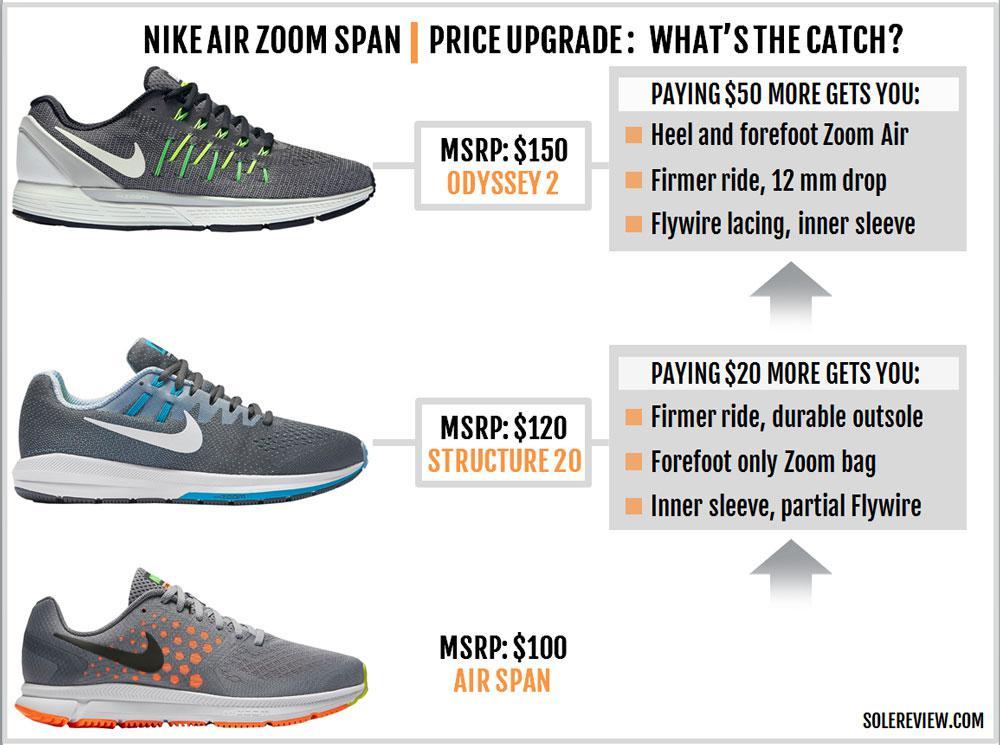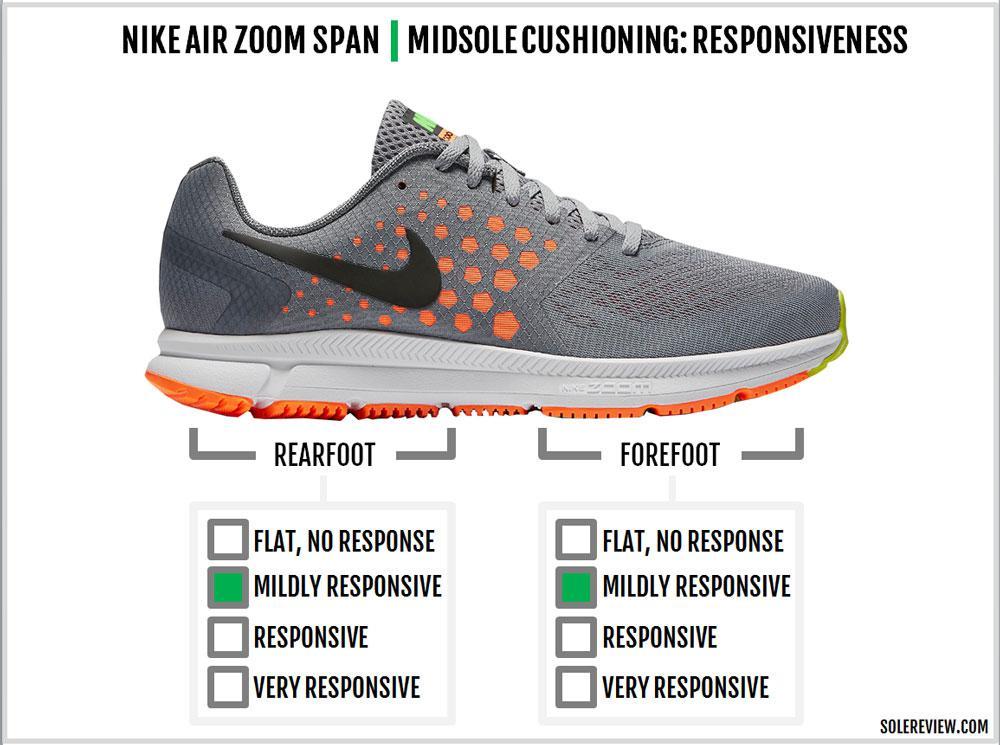The first image is the image on the left, the second image is the image on the right. Evaluate the accuracy of this statement regarding the images: "All shoes face rightward and all shoes are displayed without their matched partner.". Is it true? Answer yes or no. Yes. The first image is the image on the left, the second image is the image on the right. Considering the images on both sides, is "There is exactly two sports tennis shoes in the left image." valid? Answer yes or no. No. 